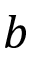Convert formula to latex. <formula><loc_0><loc_0><loc_500><loc_500>b</formula> 